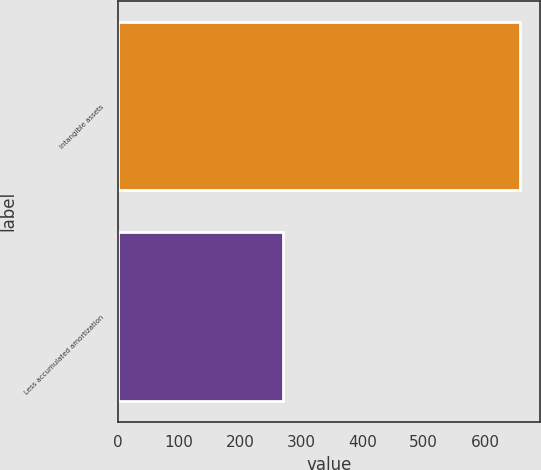Convert chart. <chart><loc_0><loc_0><loc_500><loc_500><bar_chart><fcel>Intangible assets<fcel>Less accumulated amortization<nl><fcel>658<fcel>270<nl></chart> 